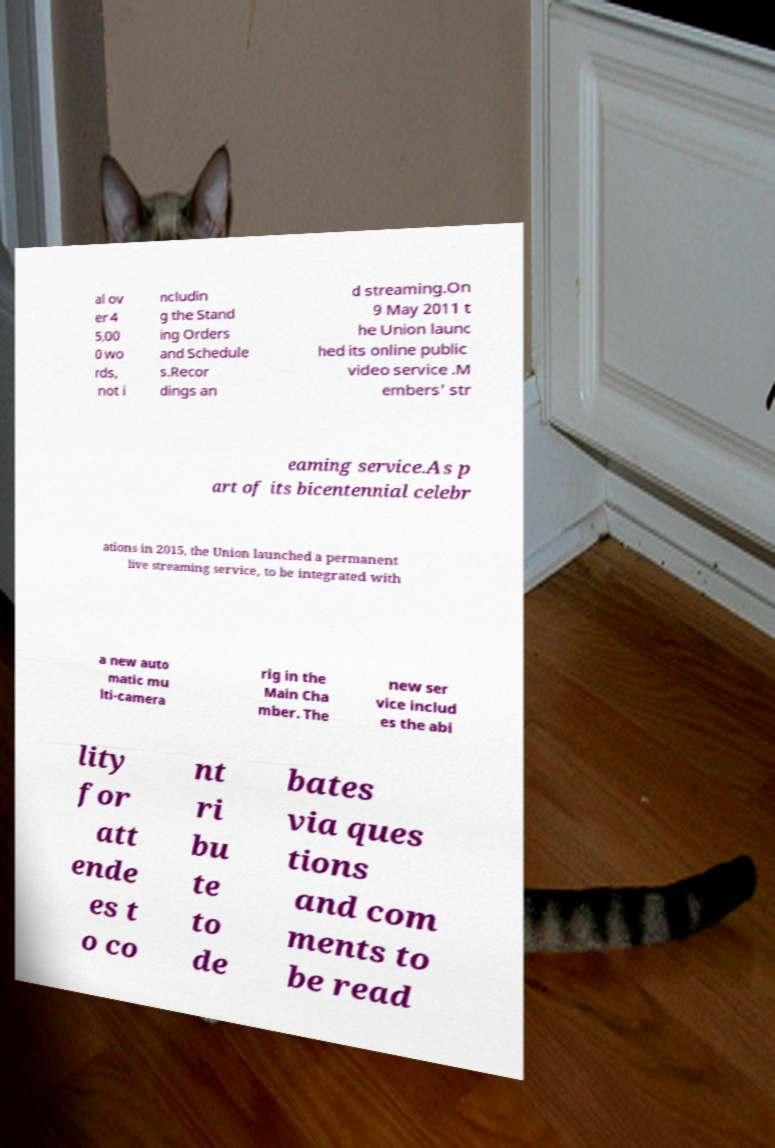Can you accurately transcribe the text from the provided image for me? al ov er 4 5,00 0 wo rds, not i ncludin g the Stand ing Orders and Schedule s.Recor dings an d streaming.On 9 May 2011 t he Union launc hed its online public video service .M embers' str eaming service.As p art of its bicentennial celebr ations in 2015, the Union launched a permanent live streaming service, to be integrated with a new auto matic mu lti-camera rig in the Main Cha mber. The new ser vice includ es the abi lity for att ende es t o co nt ri bu te to de bates via ques tions and com ments to be read 